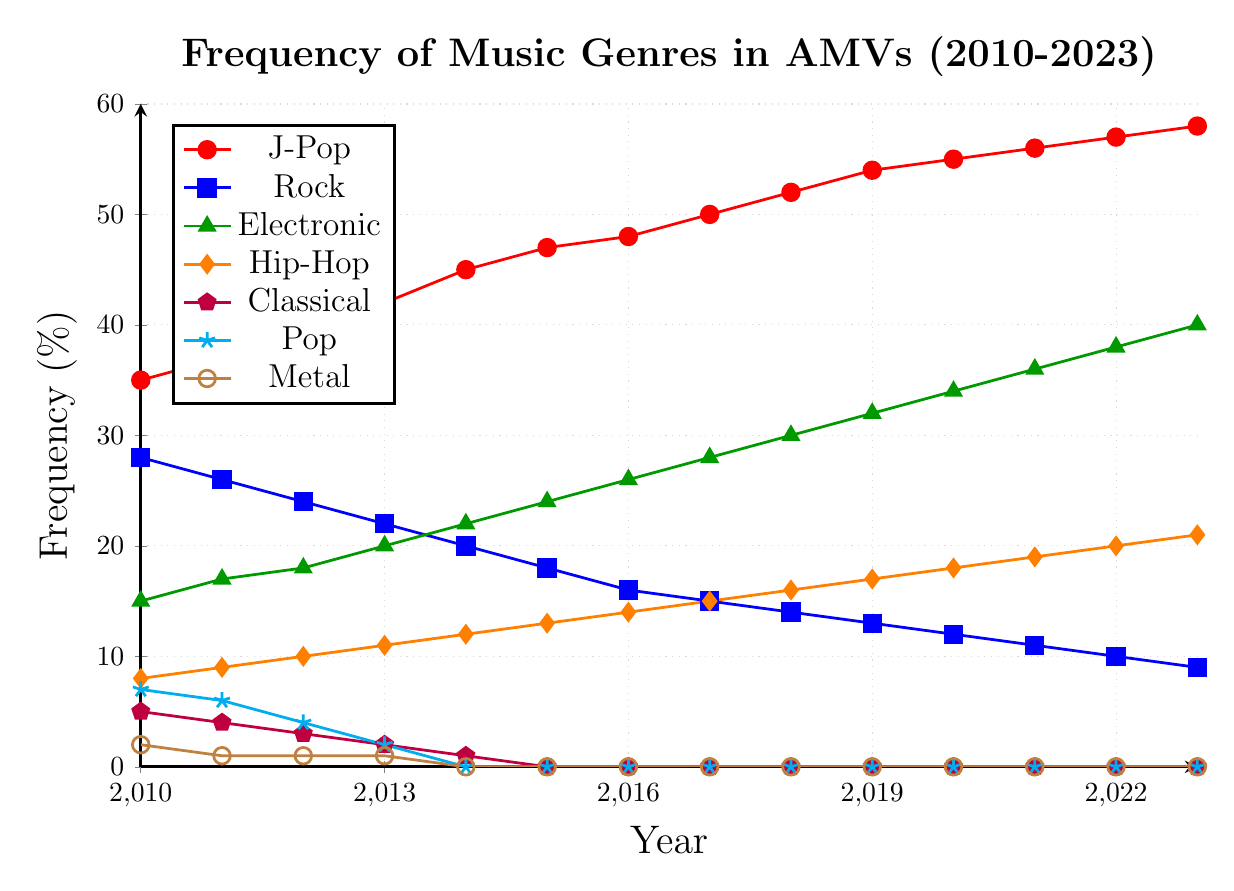What genre saw a constant increase in frequency from 2010 to 2023? J-Pop increased steadily from 35% in 2010 to 58% in 2023, Rock showed a consistent decline, and Electronic steadily increased from 15% to 40%, confirming the candidate genres. But focusing on the data points' values, J-Pop and Electronic both show constant increases. However, the largest and uninterrupted growth is seen in J-Pop from 2010 to 2023.
Answer: J-Pop Which genre had the highest decline in frequency over the years? Classical music saw a decline from 5% in 2010 to 0% in 2015 and remained at 0% until 2023. This represents a complete drop-off in usage, more so than any other genre.
Answer: Classical In which year did Pop music completely disappear from AMVs? From the plot, Pop music drops to 0% in 2014 and stays at 0% onwards.
Answer: 2014 Compare the frequency of Hip-Hop in 2020 and 2023. What is the percentage difference? In 2020, Hip-Hop's frequency was 18%, and in 2023, it was 21%. The difference is calculated as 21% - 18% = 3%.
Answer: 3% How many genres had already reached 0% frequency by 2017? By 2017, Classical, Pop, and Metal had reached 0% frequency.
Answer: 3 genres Identify the genres which increased in frequency consistently from 2010 to 2023. J-Pop, Electronic, and Hip-Hop all show a consistent increase in their frequencies across these years.
Answer: J-Pop, Electronic, Hip-Hop What was the frequency of Rock in 2023 and how does it compare to its frequency in 2010? In 2010, Rock had a frequency of 28%, and in 2023, it was 9%. Thus, it decreased by 28% - 9% = 19%.
Answer: Rock's frequency decreased by 19% Which genre had a peak frequency of 40% in 2023? According to the plot, Electronic reached 40% in 2023.
Answer: Electronic What is the overall trend for Metal music from 2010 to 2023? Metal music had a minor presence of 2% in 2010, declining to 1% in 2011, and reached 0% by 2014, remaining there through 2023.
Answer: Declining Compare the frequencies of J-Pop, Rock, and Electronic music in 2013. In 2013, J-Pop had a frequency of 42%, Rock had 22%, and Electronic had 20%. J-Pop > Rock > Electronic in this year.
Answer: 42%, 22%, 20% 